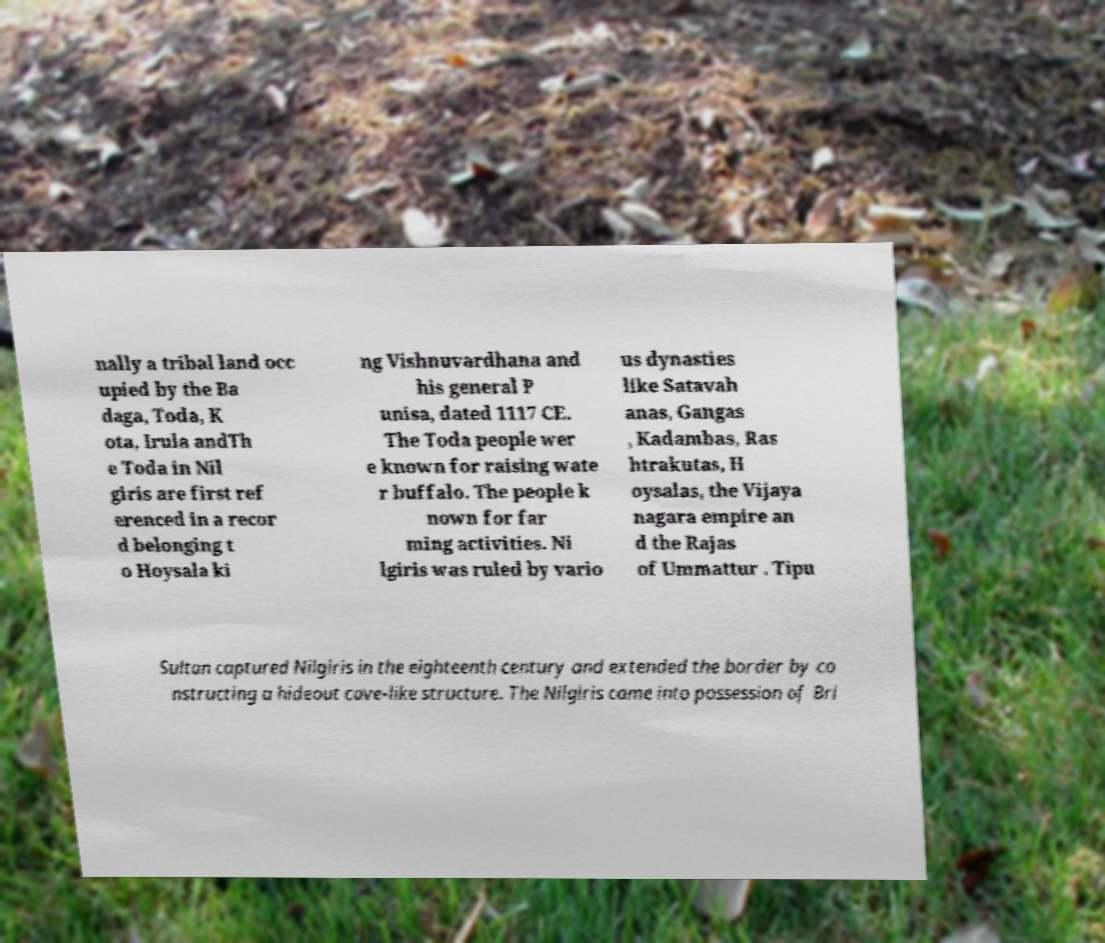Could you assist in decoding the text presented in this image and type it out clearly? nally a tribal land occ upied by the Ba daga, Toda, K ota, Irula andTh e Toda in Nil giris are first ref erenced in a recor d belonging t o Hoysala ki ng Vishnuvardhana and his general P unisa, dated 1117 CE. The Toda people wer e known for raising wate r buffalo. The people k nown for far ming activities. Ni lgiris was ruled by vario us dynasties like Satavah anas, Gangas , Kadambas, Ras htrakutas, H oysalas, the Vijaya nagara empire an d the Rajas of Ummattur . Tipu Sultan captured Nilgiris in the eighteenth century and extended the border by co nstructing a hideout cave-like structure. The Nilgiris came into possession of Bri 